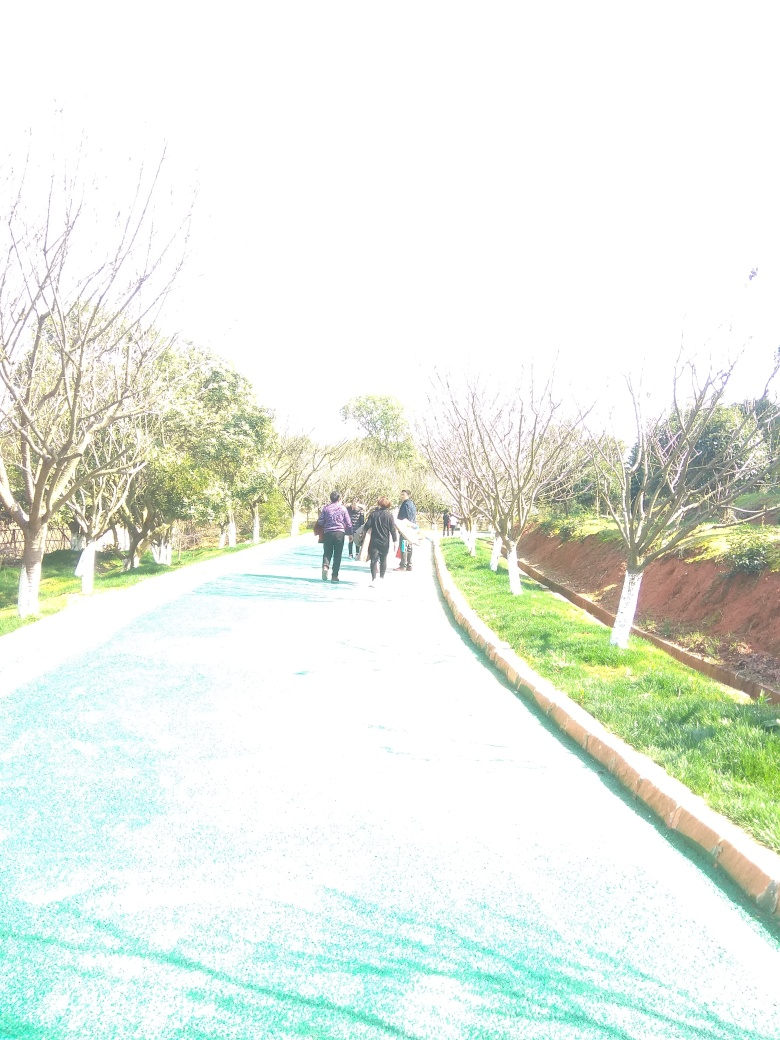What is the impact of the overexposure on the image quality? Overexposure results in photos with regions that are 'washed out' or where the highlights are so bright that they lack discernible details. For instance, in this image, overexposure has caused details to be lost in the brighter areas, such as the sky and the surfaces where sunlight is directly falling, limiting the visibility of finer details that could have contributed to a more balanced and aesthetically pleasing composition. 